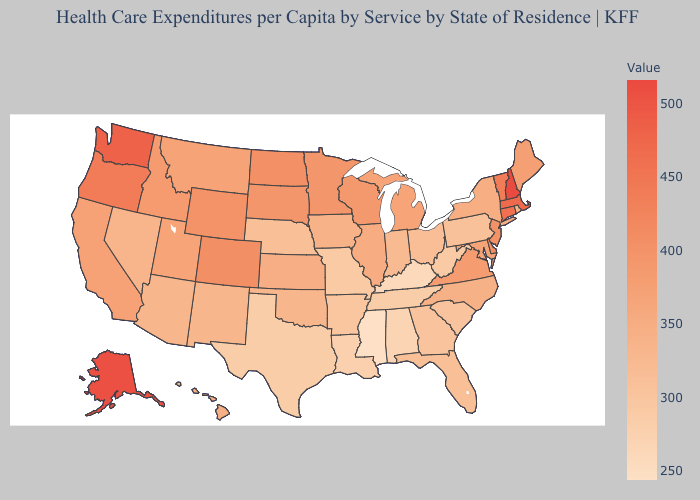Does Hawaii have a lower value than Texas?
Be succinct. No. Does Wisconsin have the lowest value in the USA?
Answer briefly. No. Does Wisconsin have the highest value in the USA?
Write a very short answer. No. Which states have the highest value in the USA?
Be succinct. New Hampshire. Does Mississippi have the lowest value in the USA?
Concise answer only. Yes. Does New Mexico have the lowest value in the West?
Give a very brief answer. Yes. 